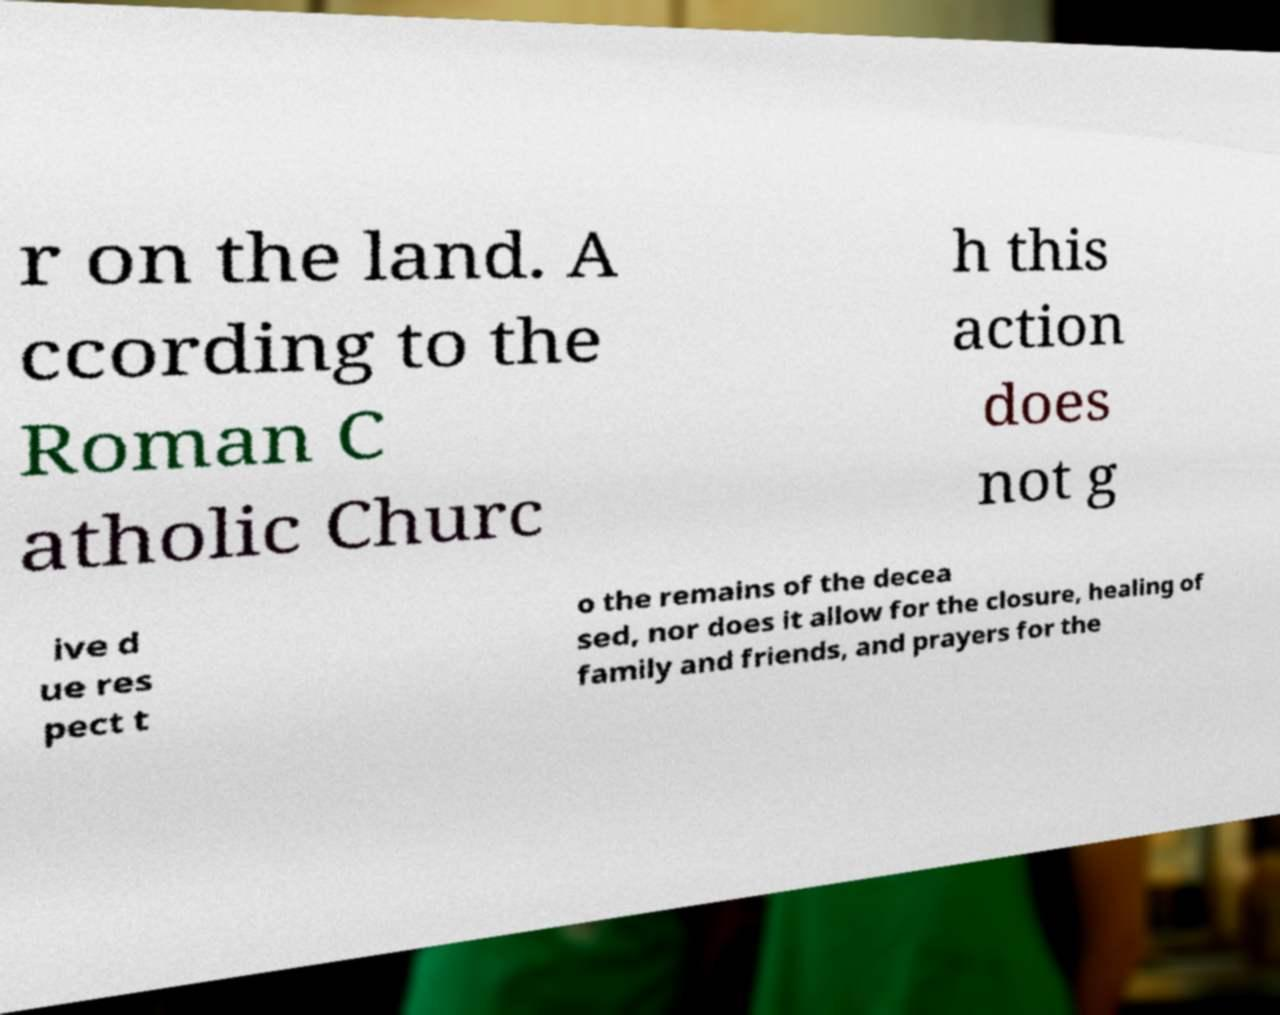There's text embedded in this image that I need extracted. Can you transcribe it verbatim? r on the land. A ccording to the Roman C atholic Churc h this action does not g ive d ue res pect t o the remains of the decea sed, nor does it allow for the closure, healing of family and friends, and prayers for the 